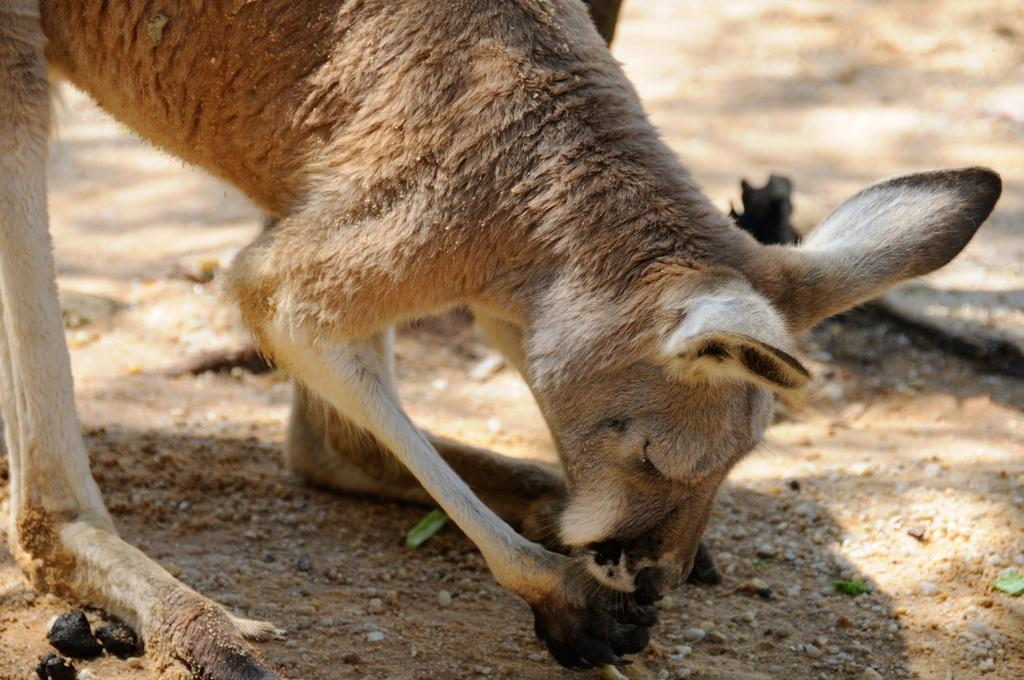What animal is in the foreground of the image? There is a kangaroo in the foreground of the image. What is the kangaroo doing in the image? The kangaroo is standing and eating something. What type of terrain can be seen in the background of the image? There is land visible in the background of the image. What type of bun is the kangaroo holding in the image? There is no bun present in the image; the kangaroo is eating something, but it is not specified as a bun. What scientific discovery is the kangaroo making in the image? There is no indication of a scientific discovery in the image; the kangaroo is simply standing and eating. 